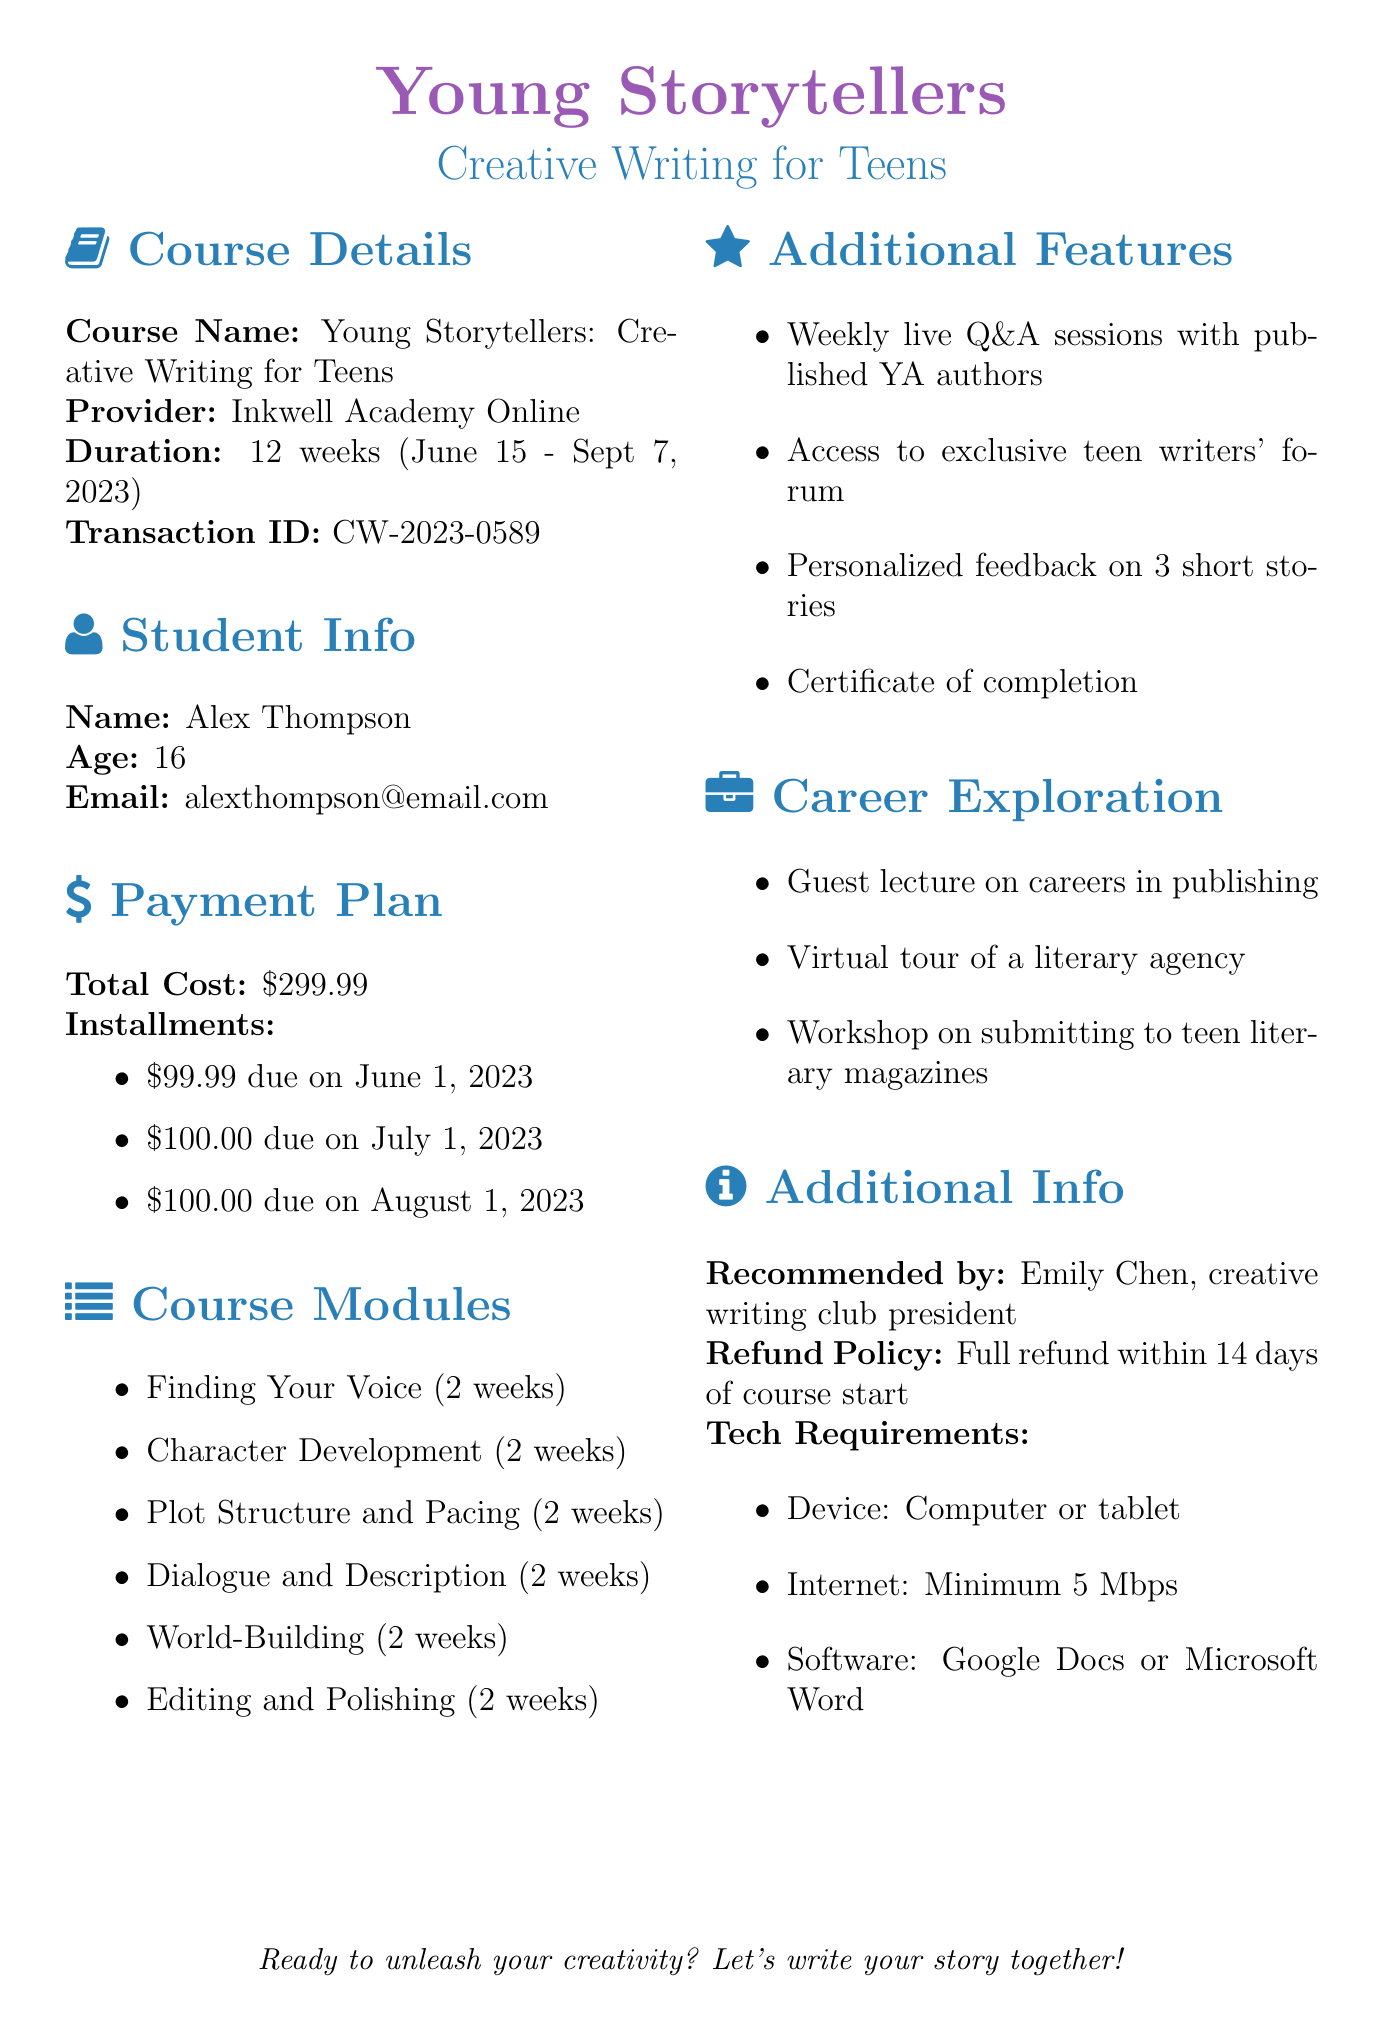What is the course name? The course name is listed in the document as "Young Storytellers: Creative Writing for Teens".
Answer: Young Storytellers: Creative Writing for Teens What is the total cost of the course? The total cost is specified in the payment plan section of the document as $299.99.
Answer: $299.99 When does the course start? The start date of the course is provided in the course details, which is June 15, 2023.
Answer: June 15, 2023 How many modules are there in the course? The course modules section lists a total of six different modules as part of the course.
Answer: 6 What is the refund policy? The refund policy is mentioned in the additional info section, stating a full refund is available within 14 days of the course start date.
Answer: Full refund within 14 days of course start Name one additional feature of the course. The document lists several additional features, one of which is "Weekly live Q&A sessions with published YA authors."
Answer: Weekly live Q&A sessions with published YA authors Who recommended the course? The document states that Emily Chen, the creative writing club president, recommended the course.
Answer: Emily Chen What type of device is required? The technical requirements mention needing a computer or tablet.
Answer: Computer or tablet 